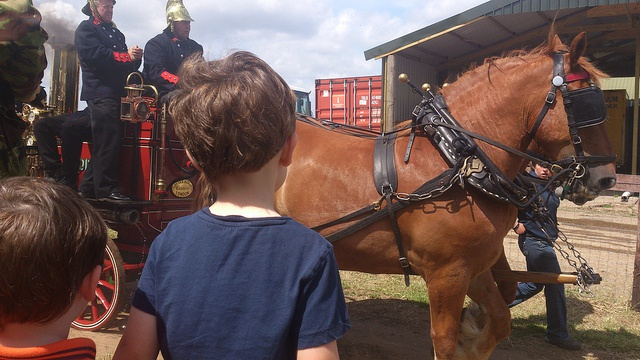Describe the objects in this image and their specific colors. I can see horse in brown, maroon, and black tones, people in brown, gray, navy, black, and darkblue tones, people in brown, black, and maroon tones, people in brown, black, and gray tones, and people in olive, black, gray, and maroon tones in this image. 